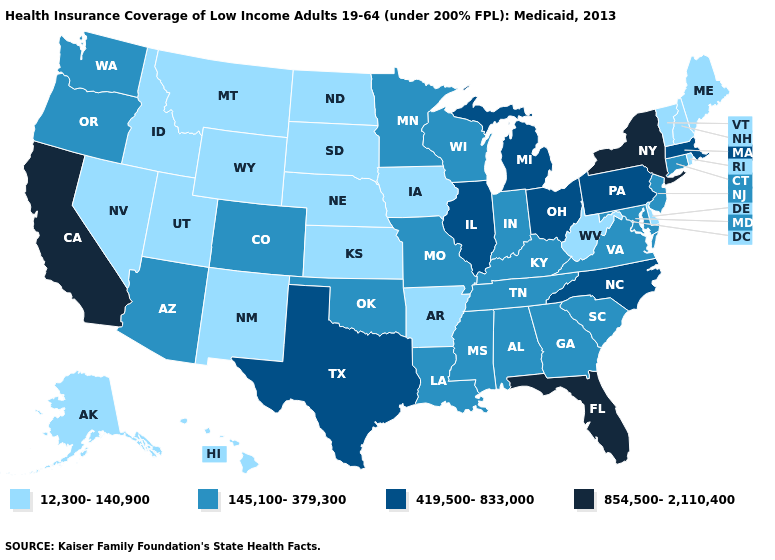Name the states that have a value in the range 145,100-379,300?
Give a very brief answer. Alabama, Arizona, Colorado, Connecticut, Georgia, Indiana, Kentucky, Louisiana, Maryland, Minnesota, Mississippi, Missouri, New Jersey, Oklahoma, Oregon, South Carolina, Tennessee, Virginia, Washington, Wisconsin. What is the value of New Jersey?
Give a very brief answer. 145,100-379,300. What is the highest value in the South ?
Concise answer only. 854,500-2,110,400. Name the states that have a value in the range 12,300-140,900?
Quick response, please. Alaska, Arkansas, Delaware, Hawaii, Idaho, Iowa, Kansas, Maine, Montana, Nebraska, Nevada, New Hampshire, New Mexico, North Dakota, Rhode Island, South Dakota, Utah, Vermont, West Virginia, Wyoming. Which states have the lowest value in the USA?
Short answer required. Alaska, Arkansas, Delaware, Hawaii, Idaho, Iowa, Kansas, Maine, Montana, Nebraska, Nevada, New Hampshire, New Mexico, North Dakota, Rhode Island, South Dakota, Utah, Vermont, West Virginia, Wyoming. Among the states that border Pennsylvania , does New York have the highest value?
Keep it brief. Yes. Does the map have missing data?
Answer briefly. No. Among the states that border Tennessee , which have the lowest value?
Answer briefly. Arkansas. Which states hav the highest value in the South?
Concise answer only. Florida. Which states have the lowest value in the South?
Short answer required. Arkansas, Delaware, West Virginia. Name the states that have a value in the range 854,500-2,110,400?
Concise answer only. California, Florida, New York. Name the states that have a value in the range 854,500-2,110,400?
Give a very brief answer. California, Florida, New York. Name the states that have a value in the range 854,500-2,110,400?
Answer briefly. California, Florida, New York. Does Georgia have a higher value than Missouri?
Keep it brief. No. What is the value of Iowa?
Quick response, please. 12,300-140,900. 